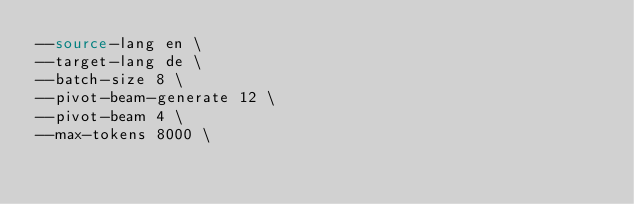Convert code to text. <code><loc_0><loc_0><loc_500><loc_500><_Bash_>--source-lang en \
--target-lang de \
--batch-size 8 \
--pivot-beam-generate 12 \
--pivot-beam 4 \
--max-tokens 8000 \</code> 